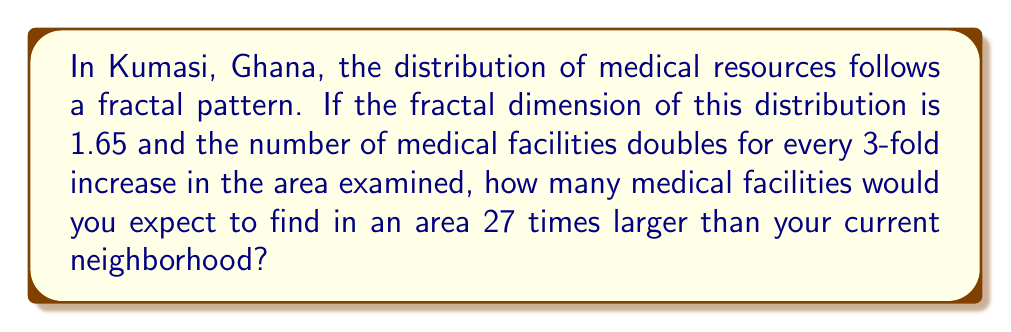Help me with this question. Let's approach this step-by-step using fractal analysis:

1) In fractal geometry, the relationship between the number of objects N and the scale factor r is given by:

   $$N = r^D$$

   where D is the fractal dimension.

2) We're told that the fractal dimension D = 1.65.

3) We're also told that the number of facilities doubles (N = 2) when the area increases by a factor of 3 (r = 3). Let's verify this:

   $$2 = 3^{1.65}$$
   $$2 ≈ 2.0133$$ (rounded to 4 decimal places)

   This confirms the given information.

4) Now, we want to find N when r = 27 (as the area is 27 times larger).

5) We can use the fractal dimension formula:

   $$N = 27^{1.65}$$

6) Calculate this:

   $$N = 27^{1.65} = 81.2384...$$

7) Since we can't have a fractional number of medical facilities, we round to the nearest whole number.
Answer: 81 medical facilities 